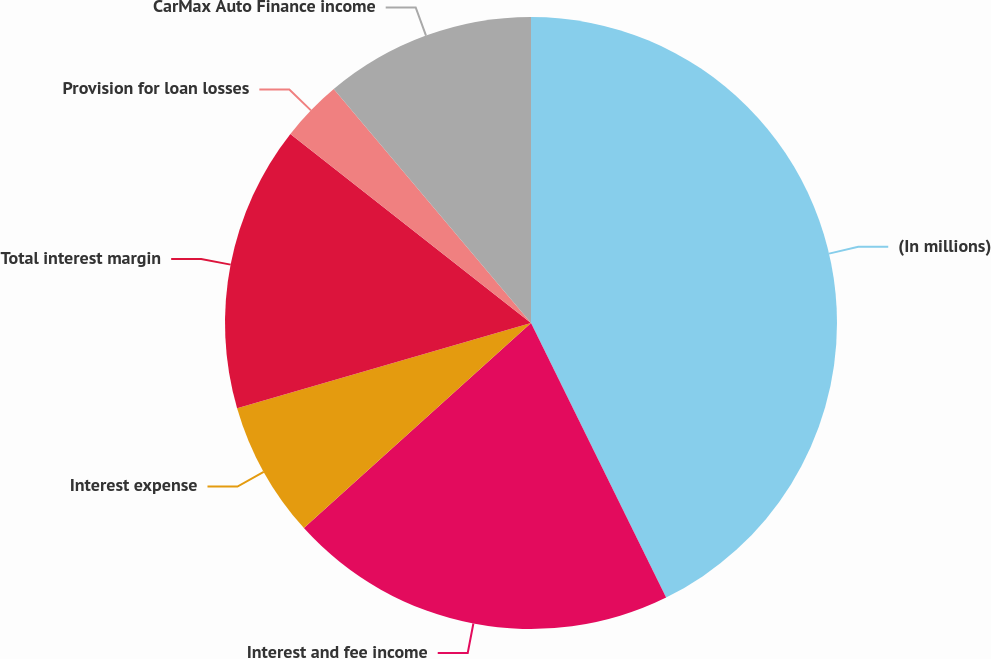<chart> <loc_0><loc_0><loc_500><loc_500><pie_chart><fcel>(In millions)<fcel>Interest and fee income<fcel>Interest expense<fcel>Total interest margin<fcel>Provision for loan losses<fcel>CarMax Auto Finance income<nl><fcel>42.72%<fcel>20.59%<fcel>7.2%<fcel>15.09%<fcel>3.25%<fcel>11.15%<nl></chart> 